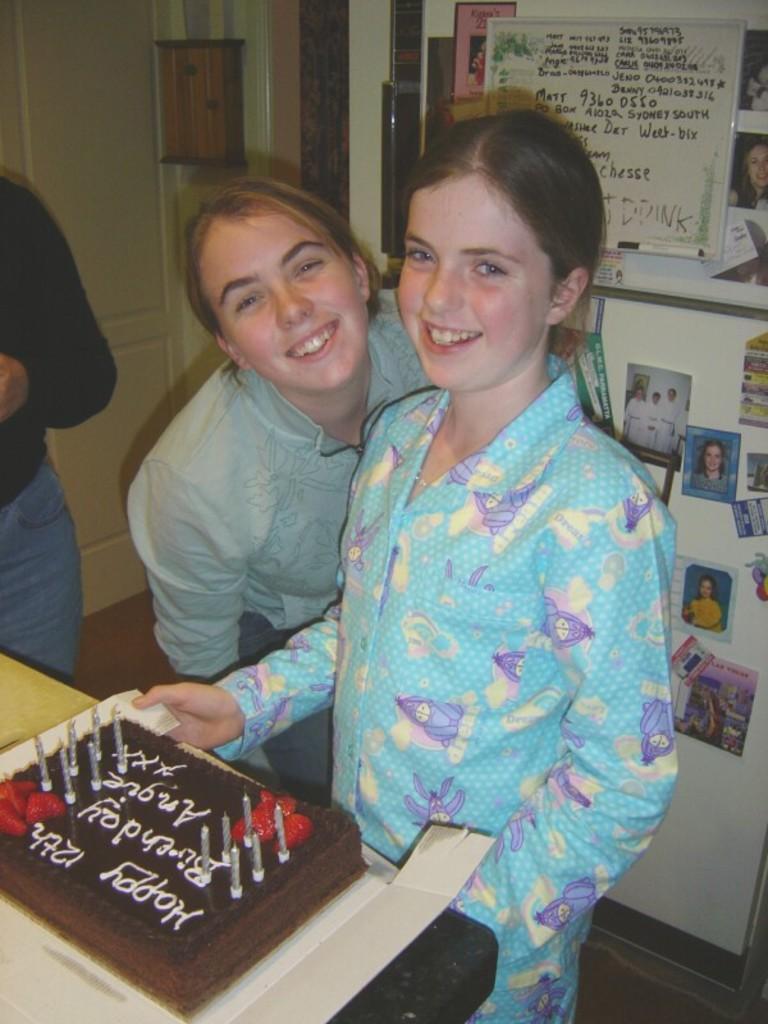Please provide a concise description of this image. This is the picture of a room. In this image there are two persons standing and smiling and there is a person standing. There is a cake on the table and there is a text and there are candles on the cake. At the back there are photos and frames on the wall and there is a door. At the bottom there is a mat. 